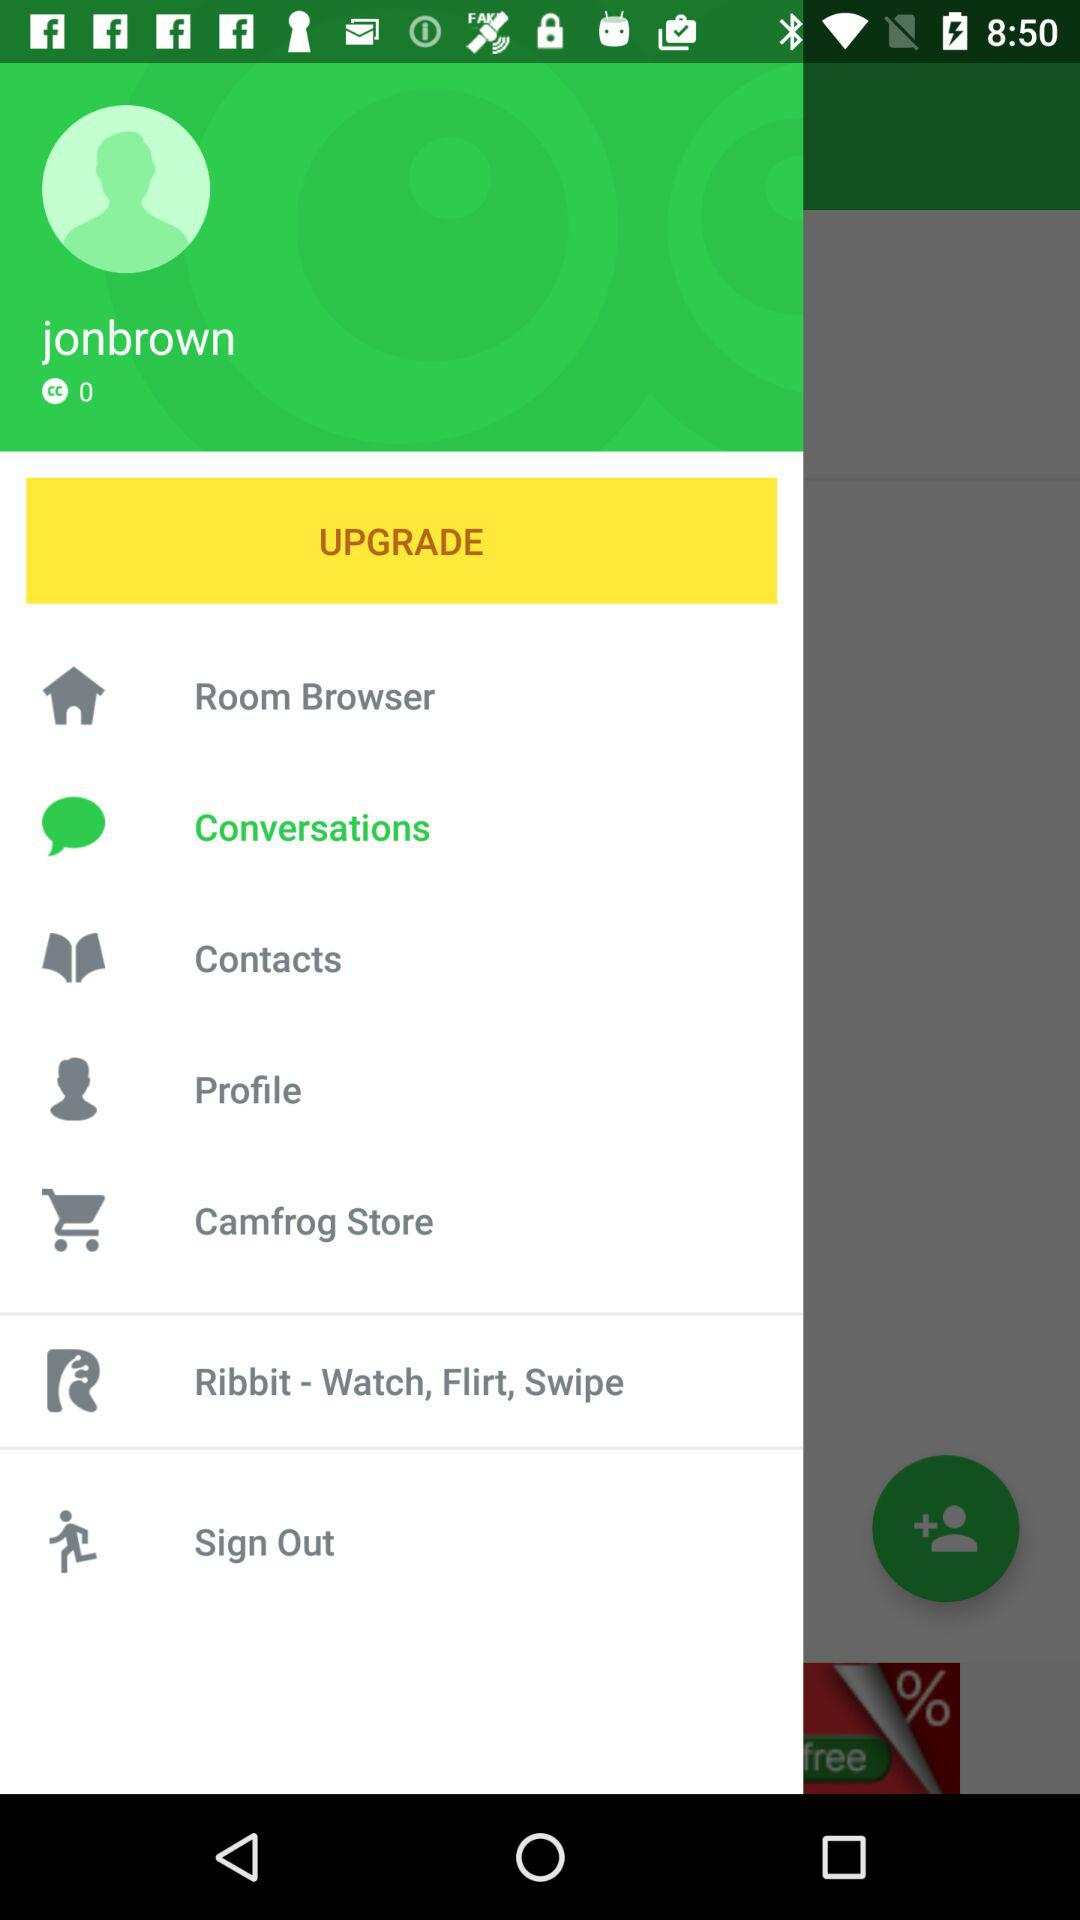What is the number of CC points? The number of CC points is 0. 